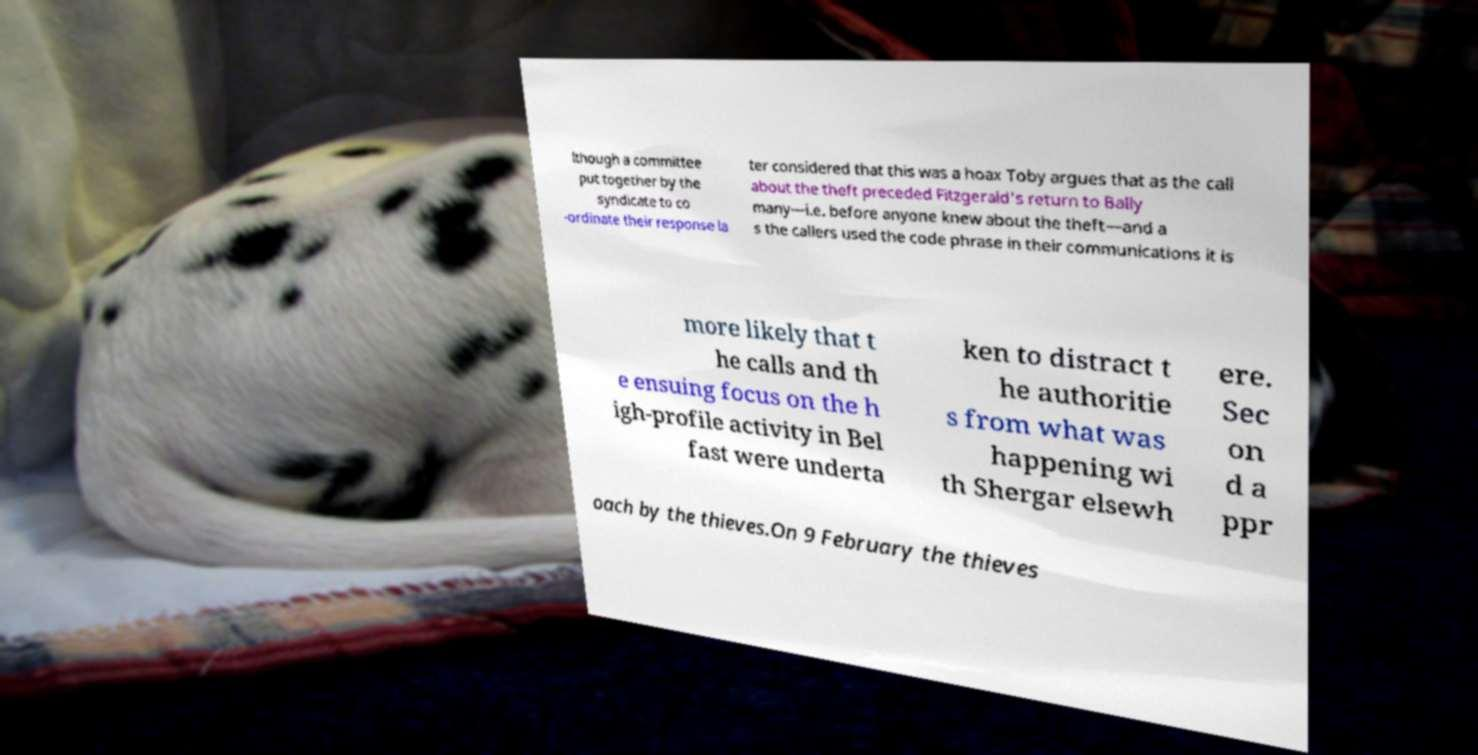For documentation purposes, I need the text within this image transcribed. Could you provide that? lthough a committee put together by the syndicate to co -ordinate their response la ter considered that this was a hoax Toby argues that as the call about the theft preceded Fitzgerald's return to Bally many—i.e. before anyone knew about the theft—and a s the callers used the code phrase in their communications it is more likely that t he calls and th e ensuing focus on the h igh-profile activity in Bel fast were underta ken to distract t he authoritie s from what was happening wi th Shergar elsewh ere. Sec on d a ppr oach by the thieves.On 9 February the thieves 